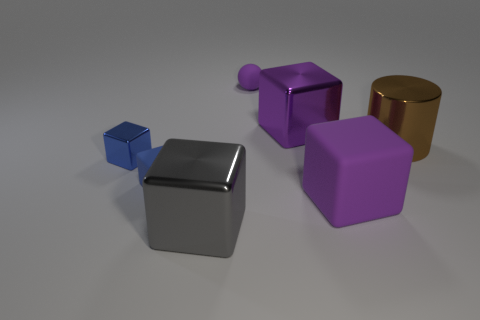Subtract 2 cubes. How many cubes are left? 3 Subtract all green blocks. Subtract all green cylinders. How many blocks are left? 5 Add 2 blue rubber objects. How many objects exist? 9 Subtract all blocks. How many objects are left? 2 Subtract 0 green cylinders. How many objects are left? 7 Subtract all big cubes. Subtract all tiny red shiny balls. How many objects are left? 4 Add 6 big purple things. How many big purple things are left? 8 Add 4 small things. How many small things exist? 7 